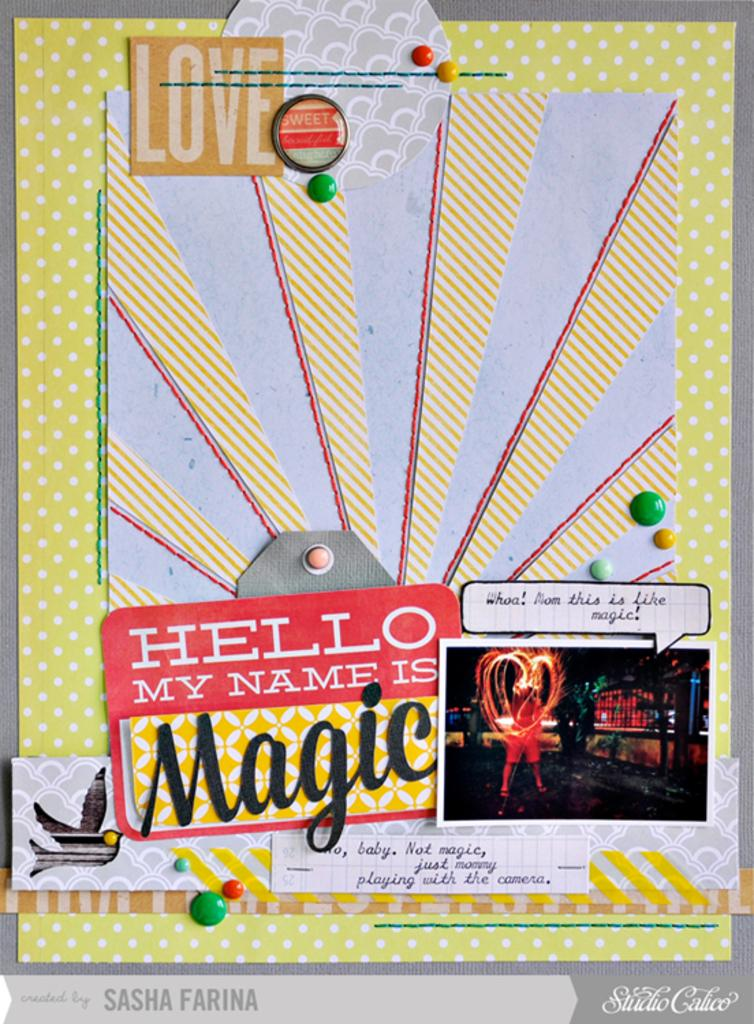Provide a one-sentence caption for the provided image. A colorful poster has a name tag that says hello my name is Magic. 